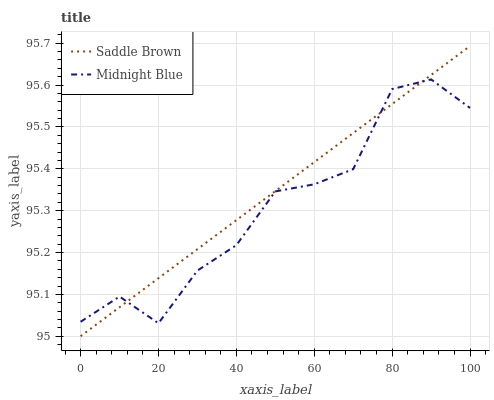Does Midnight Blue have the minimum area under the curve?
Answer yes or no. Yes. Does Saddle Brown have the maximum area under the curve?
Answer yes or no. Yes. Does Midnight Blue have the maximum area under the curve?
Answer yes or no. No. Is Saddle Brown the smoothest?
Answer yes or no. Yes. Is Midnight Blue the roughest?
Answer yes or no. Yes. Is Midnight Blue the smoothest?
Answer yes or no. No. Does Saddle Brown have the lowest value?
Answer yes or no. Yes. Does Midnight Blue have the lowest value?
Answer yes or no. No. Does Saddle Brown have the highest value?
Answer yes or no. Yes. Does Midnight Blue have the highest value?
Answer yes or no. No. Does Midnight Blue intersect Saddle Brown?
Answer yes or no. Yes. Is Midnight Blue less than Saddle Brown?
Answer yes or no. No. Is Midnight Blue greater than Saddle Brown?
Answer yes or no. No. 